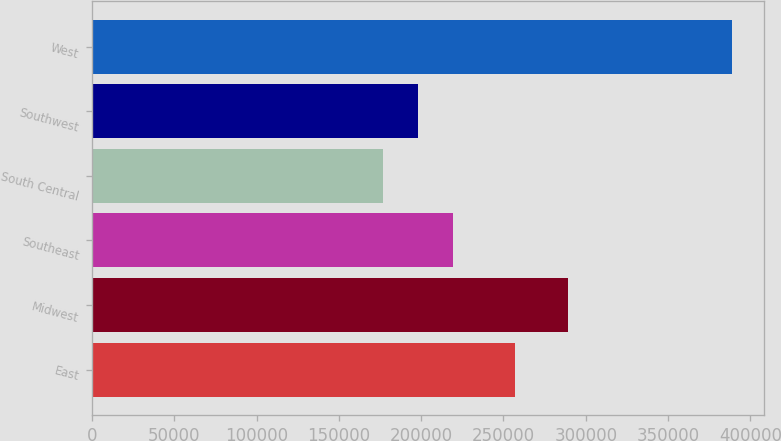Convert chart to OTSL. <chart><loc_0><loc_0><loc_500><loc_500><bar_chart><fcel>East<fcel>Midwest<fcel>Southeast<fcel>South Central<fcel>Southwest<fcel>West<nl><fcel>256800<fcel>289400<fcel>219380<fcel>177000<fcel>198190<fcel>388900<nl></chart> 